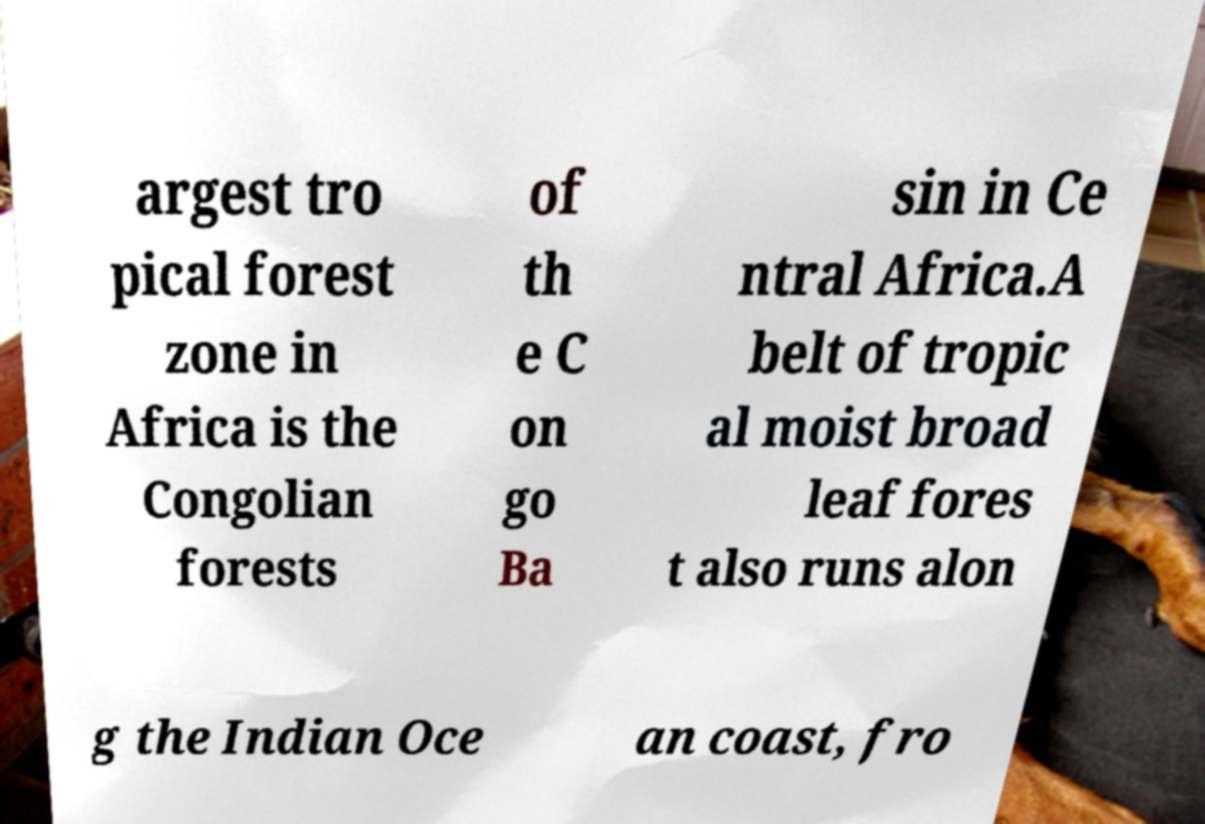For documentation purposes, I need the text within this image transcribed. Could you provide that? argest tro pical forest zone in Africa is the Congolian forests of th e C on go Ba sin in Ce ntral Africa.A belt of tropic al moist broad leaf fores t also runs alon g the Indian Oce an coast, fro 